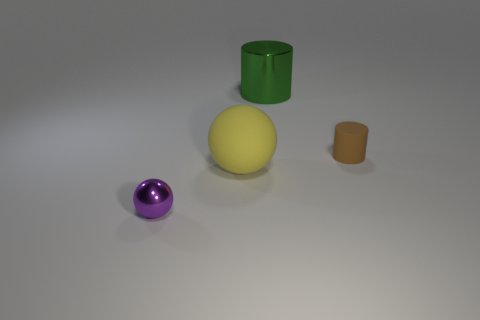The brown object has what shape? The brown object in the image is a small cylinder, exhibiting a classic cylindrical shape with circular ends and a long, straight side. 